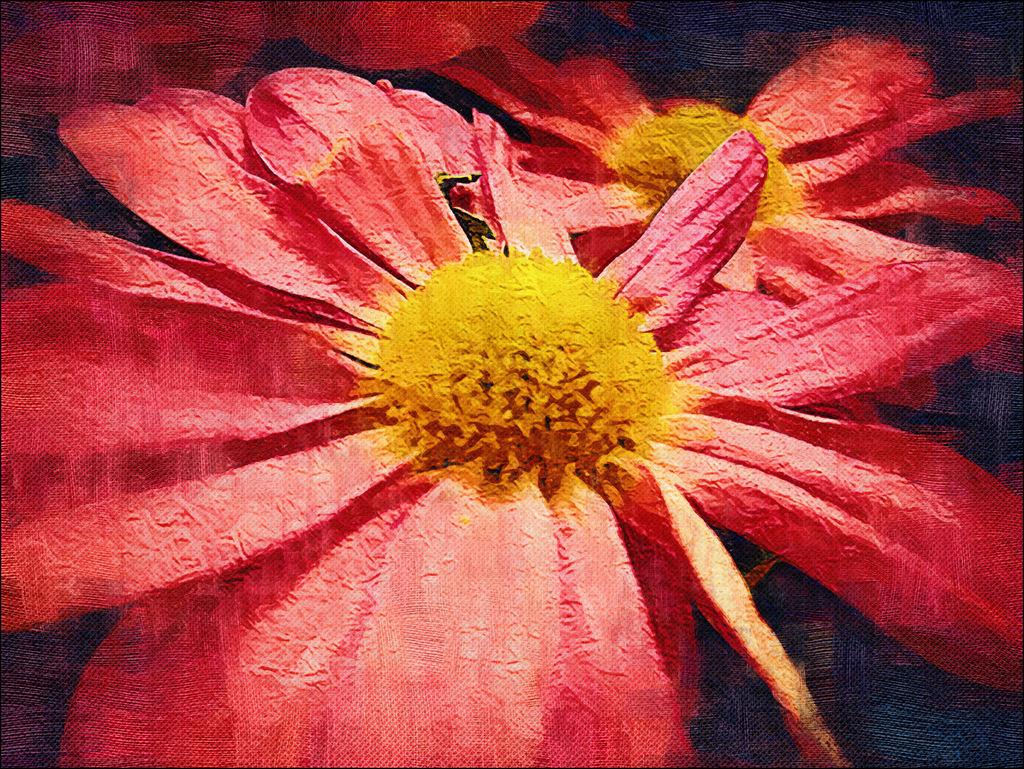What type of visual is the image? The image is a poster. What can be seen on the poster? There are flowers visible in the image. What rule is being enforced by the flowers in the image? There is no rule being enforced by the flowers in the image, as they are simply a decorative element on the poster. 